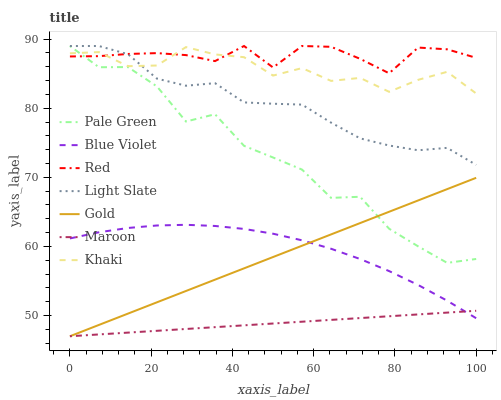Does Maroon have the minimum area under the curve?
Answer yes or no. Yes. Does Red have the maximum area under the curve?
Answer yes or no. Yes. Does Gold have the minimum area under the curve?
Answer yes or no. No. Does Gold have the maximum area under the curve?
Answer yes or no. No. Is Maroon the smoothest?
Answer yes or no. Yes. Is Pale Green the roughest?
Answer yes or no. Yes. Is Gold the smoothest?
Answer yes or no. No. Is Gold the roughest?
Answer yes or no. No. Does Gold have the lowest value?
Answer yes or no. Yes. Does Light Slate have the lowest value?
Answer yes or no. No. Does Red have the highest value?
Answer yes or no. Yes. Does Gold have the highest value?
Answer yes or no. No. Is Blue Violet less than Light Slate?
Answer yes or no. Yes. Is Light Slate greater than Maroon?
Answer yes or no. Yes. Does Khaki intersect Pale Green?
Answer yes or no. Yes. Is Khaki less than Pale Green?
Answer yes or no. No. Is Khaki greater than Pale Green?
Answer yes or no. No. Does Blue Violet intersect Light Slate?
Answer yes or no. No. 